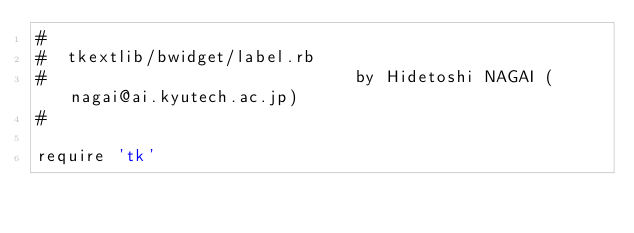Convert code to text. <code><loc_0><loc_0><loc_500><loc_500><_Ruby_>#
#  tkextlib/bwidget/label.rb
#                               by Hidetoshi NAGAI (nagai@ai.kyutech.ac.jp)
#

require 'tk'</code> 